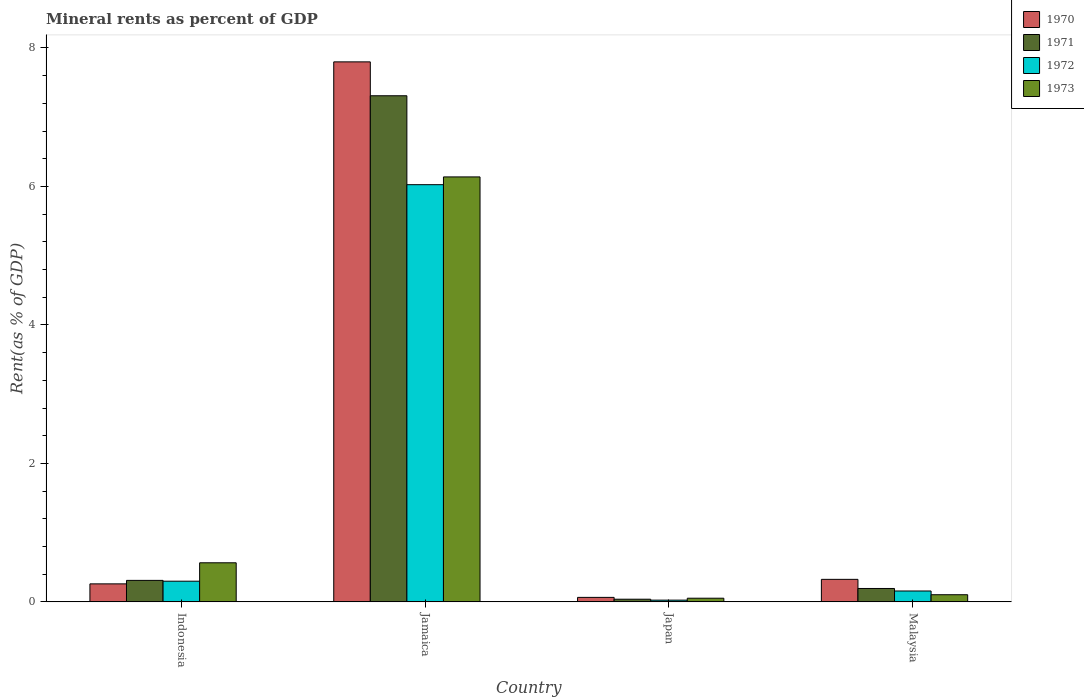How many different coloured bars are there?
Provide a short and direct response. 4. How many groups of bars are there?
Provide a succinct answer. 4. Are the number of bars per tick equal to the number of legend labels?
Offer a very short reply. Yes. How many bars are there on the 4th tick from the right?
Provide a succinct answer. 4. What is the mineral rent in 1970 in Indonesia?
Give a very brief answer. 0.26. Across all countries, what is the maximum mineral rent in 1973?
Offer a terse response. 6.14. Across all countries, what is the minimum mineral rent in 1973?
Your answer should be very brief. 0.05. In which country was the mineral rent in 1972 maximum?
Offer a terse response. Jamaica. In which country was the mineral rent in 1973 minimum?
Your response must be concise. Japan. What is the total mineral rent in 1970 in the graph?
Provide a succinct answer. 8.45. What is the difference between the mineral rent in 1971 in Jamaica and that in Japan?
Give a very brief answer. 7.27. What is the difference between the mineral rent in 1971 in Jamaica and the mineral rent in 1970 in Japan?
Give a very brief answer. 7.25. What is the average mineral rent in 1973 per country?
Ensure brevity in your answer.  1.71. What is the difference between the mineral rent of/in 1970 and mineral rent of/in 1971 in Jamaica?
Ensure brevity in your answer.  0.49. What is the ratio of the mineral rent in 1970 in Japan to that in Malaysia?
Your response must be concise. 0.2. What is the difference between the highest and the second highest mineral rent in 1971?
Keep it short and to the point. 0.12. What is the difference between the highest and the lowest mineral rent in 1972?
Keep it short and to the point. 6. In how many countries, is the mineral rent in 1973 greater than the average mineral rent in 1973 taken over all countries?
Provide a succinct answer. 1. Is it the case that in every country, the sum of the mineral rent in 1971 and mineral rent in 1970 is greater than the sum of mineral rent in 1973 and mineral rent in 1972?
Provide a short and direct response. No. What does the 3rd bar from the right in Indonesia represents?
Provide a short and direct response. 1971. How many bars are there?
Offer a terse response. 16. Are the values on the major ticks of Y-axis written in scientific E-notation?
Offer a terse response. No. Does the graph contain grids?
Your answer should be compact. No. How are the legend labels stacked?
Provide a succinct answer. Vertical. What is the title of the graph?
Keep it short and to the point. Mineral rents as percent of GDP. What is the label or title of the X-axis?
Give a very brief answer. Country. What is the label or title of the Y-axis?
Your answer should be compact. Rent(as % of GDP). What is the Rent(as % of GDP) in 1970 in Indonesia?
Give a very brief answer. 0.26. What is the Rent(as % of GDP) in 1971 in Indonesia?
Make the answer very short. 0.31. What is the Rent(as % of GDP) of 1972 in Indonesia?
Offer a very short reply. 0.3. What is the Rent(as % of GDP) in 1973 in Indonesia?
Offer a very short reply. 0.56. What is the Rent(as % of GDP) in 1970 in Jamaica?
Provide a short and direct response. 7.8. What is the Rent(as % of GDP) in 1971 in Jamaica?
Give a very brief answer. 7.31. What is the Rent(as % of GDP) in 1972 in Jamaica?
Provide a short and direct response. 6.03. What is the Rent(as % of GDP) in 1973 in Jamaica?
Your answer should be compact. 6.14. What is the Rent(as % of GDP) of 1970 in Japan?
Give a very brief answer. 0.06. What is the Rent(as % of GDP) in 1971 in Japan?
Your response must be concise. 0.04. What is the Rent(as % of GDP) in 1972 in Japan?
Give a very brief answer. 0.03. What is the Rent(as % of GDP) in 1973 in Japan?
Keep it short and to the point. 0.05. What is the Rent(as % of GDP) of 1970 in Malaysia?
Make the answer very short. 0.33. What is the Rent(as % of GDP) in 1971 in Malaysia?
Your answer should be compact. 0.19. What is the Rent(as % of GDP) of 1972 in Malaysia?
Offer a terse response. 0.16. What is the Rent(as % of GDP) of 1973 in Malaysia?
Provide a succinct answer. 0.1. Across all countries, what is the maximum Rent(as % of GDP) in 1970?
Your answer should be compact. 7.8. Across all countries, what is the maximum Rent(as % of GDP) of 1971?
Ensure brevity in your answer.  7.31. Across all countries, what is the maximum Rent(as % of GDP) in 1972?
Offer a terse response. 6.03. Across all countries, what is the maximum Rent(as % of GDP) of 1973?
Ensure brevity in your answer.  6.14. Across all countries, what is the minimum Rent(as % of GDP) in 1970?
Offer a very short reply. 0.06. Across all countries, what is the minimum Rent(as % of GDP) of 1971?
Give a very brief answer. 0.04. Across all countries, what is the minimum Rent(as % of GDP) of 1972?
Provide a succinct answer. 0.03. Across all countries, what is the minimum Rent(as % of GDP) in 1973?
Provide a short and direct response. 0.05. What is the total Rent(as % of GDP) in 1970 in the graph?
Offer a very short reply. 8.45. What is the total Rent(as % of GDP) in 1971 in the graph?
Your response must be concise. 7.85. What is the total Rent(as % of GDP) in 1972 in the graph?
Keep it short and to the point. 6.51. What is the total Rent(as % of GDP) of 1973 in the graph?
Give a very brief answer. 6.86. What is the difference between the Rent(as % of GDP) of 1970 in Indonesia and that in Jamaica?
Your response must be concise. -7.54. What is the difference between the Rent(as % of GDP) in 1971 in Indonesia and that in Jamaica?
Provide a succinct answer. -7. What is the difference between the Rent(as % of GDP) in 1972 in Indonesia and that in Jamaica?
Provide a succinct answer. -5.73. What is the difference between the Rent(as % of GDP) in 1973 in Indonesia and that in Jamaica?
Provide a short and direct response. -5.57. What is the difference between the Rent(as % of GDP) of 1970 in Indonesia and that in Japan?
Provide a succinct answer. 0.2. What is the difference between the Rent(as % of GDP) in 1971 in Indonesia and that in Japan?
Your answer should be compact. 0.27. What is the difference between the Rent(as % of GDP) of 1972 in Indonesia and that in Japan?
Give a very brief answer. 0.27. What is the difference between the Rent(as % of GDP) of 1973 in Indonesia and that in Japan?
Offer a very short reply. 0.51. What is the difference between the Rent(as % of GDP) of 1970 in Indonesia and that in Malaysia?
Offer a very short reply. -0.07. What is the difference between the Rent(as % of GDP) in 1971 in Indonesia and that in Malaysia?
Give a very brief answer. 0.12. What is the difference between the Rent(as % of GDP) in 1972 in Indonesia and that in Malaysia?
Keep it short and to the point. 0.14. What is the difference between the Rent(as % of GDP) of 1973 in Indonesia and that in Malaysia?
Make the answer very short. 0.46. What is the difference between the Rent(as % of GDP) of 1970 in Jamaica and that in Japan?
Provide a succinct answer. 7.73. What is the difference between the Rent(as % of GDP) in 1971 in Jamaica and that in Japan?
Keep it short and to the point. 7.27. What is the difference between the Rent(as % of GDP) in 1972 in Jamaica and that in Japan?
Provide a succinct answer. 6. What is the difference between the Rent(as % of GDP) in 1973 in Jamaica and that in Japan?
Your response must be concise. 6.08. What is the difference between the Rent(as % of GDP) in 1970 in Jamaica and that in Malaysia?
Provide a succinct answer. 7.47. What is the difference between the Rent(as % of GDP) in 1971 in Jamaica and that in Malaysia?
Your response must be concise. 7.12. What is the difference between the Rent(as % of GDP) in 1972 in Jamaica and that in Malaysia?
Your answer should be very brief. 5.87. What is the difference between the Rent(as % of GDP) in 1973 in Jamaica and that in Malaysia?
Offer a terse response. 6.03. What is the difference between the Rent(as % of GDP) in 1970 in Japan and that in Malaysia?
Ensure brevity in your answer.  -0.26. What is the difference between the Rent(as % of GDP) of 1971 in Japan and that in Malaysia?
Your answer should be compact. -0.16. What is the difference between the Rent(as % of GDP) of 1972 in Japan and that in Malaysia?
Provide a short and direct response. -0.13. What is the difference between the Rent(as % of GDP) of 1973 in Japan and that in Malaysia?
Your answer should be compact. -0.05. What is the difference between the Rent(as % of GDP) of 1970 in Indonesia and the Rent(as % of GDP) of 1971 in Jamaica?
Make the answer very short. -7.05. What is the difference between the Rent(as % of GDP) of 1970 in Indonesia and the Rent(as % of GDP) of 1972 in Jamaica?
Provide a short and direct response. -5.77. What is the difference between the Rent(as % of GDP) of 1970 in Indonesia and the Rent(as % of GDP) of 1973 in Jamaica?
Provide a succinct answer. -5.88. What is the difference between the Rent(as % of GDP) of 1971 in Indonesia and the Rent(as % of GDP) of 1972 in Jamaica?
Make the answer very short. -5.72. What is the difference between the Rent(as % of GDP) in 1971 in Indonesia and the Rent(as % of GDP) in 1973 in Jamaica?
Give a very brief answer. -5.83. What is the difference between the Rent(as % of GDP) of 1972 in Indonesia and the Rent(as % of GDP) of 1973 in Jamaica?
Your answer should be very brief. -5.84. What is the difference between the Rent(as % of GDP) of 1970 in Indonesia and the Rent(as % of GDP) of 1971 in Japan?
Keep it short and to the point. 0.22. What is the difference between the Rent(as % of GDP) of 1970 in Indonesia and the Rent(as % of GDP) of 1972 in Japan?
Give a very brief answer. 0.23. What is the difference between the Rent(as % of GDP) in 1970 in Indonesia and the Rent(as % of GDP) in 1973 in Japan?
Give a very brief answer. 0.21. What is the difference between the Rent(as % of GDP) of 1971 in Indonesia and the Rent(as % of GDP) of 1972 in Japan?
Keep it short and to the point. 0.29. What is the difference between the Rent(as % of GDP) of 1971 in Indonesia and the Rent(as % of GDP) of 1973 in Japan?
Give a very brief answer. 0.26. What is the difference between the Rent(as % of GDP) in 1972 in Indonesia and the Rent(as % of GDP) in 1973 in Japan?
Offer a terse response. 0.25. What is the difference between the Rent(as % of GDP) in 1970 in Indonesia and the Rent(as % of GDP) in 1971 in Malaysia?
Your answer should be very brief. 0.07. What is the difference between the Rent(as % of GDP) of 1970 in Indonesia and the Rent(as % of GDP) of 1972 in Malaysia?
Give a very brief answer. 0.1. What is the difference between the Rent(as % of GDP) of 1970 in Indonesia and the Rent(as % of GDP) of 1973 in Malaysia?
Your response must be concise. 0.16. What is the difference between the Rent(as % of GDP) of 1971 in Indonesia and the Rent(as % of GDP) of 1972 in Malaysia?
Provide a short and direct response. 0.15. What is the difference between the Rent(as % of GDP) of 1971 in Indonesia and the Rent(as % of GDP) of 1973 in Malaysia?
Provide a succinct answer. 0.21. What is the difference between the Rent(as % of GDP) in 1972 in Indonesia and the Rent(as % of GDP) in 1973 in Malaysia?
Keep it short and to the point. 0.2. What is the difference between the Rent(as % of GDP) in 1970 in Jamaica and the Rent(as % of GDP) in 1971 in Japan?
Provide a short and direct response. 7.76. What is the difference between the Rent(as % of GDP) in 1970 in Jamaica and the Rent(as % of GDP) in 1972 in Japan?
Offer a terse response. 7.77. What is the difference between the Rent(as % of GDP) in 1970 in Jamaica and the Rent(as % of GDP) in 1973 in Japan?
Make the answer very short. 7.75. What is the difference between the Rent(as % of GDP) in 1971 in Jamaica and the Rent(as % of GDP) in 1972 in Japan?
Your answer should be compact. 7.28. What is the difference between the Rent(as % of GDP) of 1971 in Jamaica and the Rent(as % of GDP) of 1973 in Japan?
Your answer should be very brief. 7.26. What is the difference between the Rent(as % of GDP) of 1972 in Jamaica and the Rent(as % of GDP) of 1973 in Japan?
Your answer should be compact. 5.97. What is the difference between the Rent(as % of GDP) of 1970 in Jamaica and the Rent(as % of GDP) of 1971 in Malaysia?
Make the answer very short. 7.61. What is the difference between the Rent(as % of GDP) in 1970 in Jamaica and the Rent(as % of GDP) in 1972 in Malaysia?
Offer a very short reply. 7.64. What is the difference between the Rent(as % of GDP) of 1970 in Jamaica and the Rent(as % of GDP) of 1973 in Malaysia?
Keep it short and to the point. 7.7. What is the difference between the Rent(as % of GDP) of 1971 in Jamaica and the Rent(as % of GDP) of 1972 in Malaysia?
Your answer should be very brief. 7.15. What is the difference between the Rent(as % of GDP) in 1971 in Jamaica and the Rent(as % of GDP) in 1973 in Malaysia?
Make the answer very short. 7.21. What is the difference between the Rent(as % of GDP) of 1972 in Jamaica and the Rent(as % of GDP) of 1973 in Malaysia?
Your answer should be compact. 5.92. What is the difference between the Rent(as % of GDP) in 1970 in Japan and the Rent(as % of GDP) in 1971 in Malaysia?
Your answer should be compact. -0.13. What is the difference between the Rent(as % of GDP) in 1970 in Japan and the Rent(as % of GDP) in 1972 in Malaysia?
Your answer should be compact. -0.09. What is the difference between the Rent(as % of GDP) in 1970 in Japan and the Rent(as % of GDP) in 1973 in Malaysia?
Offer a very short reply. -0.04. What is the difference between the Rent(as % of GDP) in 1971 in Japan and the Rent(as % of GDP) in 1972 in Malaysia?
Your response must be concise. -0.12. What is the difference between the Rent(as % of GDP) of 1971 in Japan and the Rent(as % of GDP) of 1973 in Malaysia?
Offer a very short reply. -0.06. What is the difference between the Rent(as % of GDP) of 1972 in Japan and the Rent(as % of GDP) of 1973 in Malaysia?
Give a very brief answer. -0.08. What is the average Rent(as % of GDP) in 1970 per country?
Make the answer very short. 2.11. What is the average Rent(as % of GDP) in 1971 per country?
Give a very brief answer. 1.96. What is the average Rent(as % of GDP) of 1972 per country?
Offer a very short reply. 1.63. What is the average Rent(as % of GDP) in 1973 per country?
Provide a short and direct response. 1.71. What is the difference between the Rent(as % of GDP) of 1970 and Rent(as % of GDP) of 1971 in Indonesia?
Keep it short and to the point. -0.05. What is the difference between the Rent(as % of GDP) in 1970 and Rent(as % of GDP) in 1972 in Indonesia?
Your answer should be very brief. -0.04. What is the difference between the Rent(as % of GDP) in 1970 and Rent(as % of GDP) in 1973 in Indonesia?
Make the answer very short. -0.3. What is the difference between the Rent(as % of GDP) in 1971 and Rent(as % of GDP) in 1972 in Indonesia?
Offer a very short reply. 0.01. What is the difference between the Rent(as % of GDP) of 1971 and Rent(as % of GDP) of 1973 in Indonesia?
Make the answer very short. -0.25. What is the difference between the Rent(as % of GDP) of 1972 and Rent(as % of GDP) of 1973 in Indonesia?
Keep it short and to the point. -0.27. What is the difference between the Rent(as % of GDP) in 1970 and Rent(as % of GDP) in 1971 in Jamaica?
Offer a very short reply. 0.49. What is the difference between the Rent(as % of GDP) of 1970 and Rent(as % of GDP) of 1972 in Jamaica?
Your answer should be compact. 1.77. What is the difference between the Rent(as % of GDP) of 1970 and Rent(as % of GDP) of 1973 in Jamaica?
Give a very brief answer. 1.66. What is the difference between the Rent(as % of GDP) of 1971 and Rent(as % of GDP) of 1972 in Jamaica?
Ensure brevity in your answer.  1.28. What is the difference between the Rent(as % of GDP) in 1971 and Rent(as % of GDP) in 1973 in Jamaica?
Ensure brevity in your answer.  1.17. What is the difference between the Rent(as % of GDP) in 1972 and Rent(as % of GDP) in 1973 in Jamaica?
Ensure brevity in your answer.  -0.11. What is the difference between the Rent(as % of GDP) in 1970 and Rent(as % of GDP) in 1971 in Japan?
Offer a terse response. 0.03. What is the difference between the Rent(as % of GDP) of 1970 and Rent(as % of GDP) of 1972 in Japan?
Provide a succinct answer. 0.04. What is the difference between the Rent(as % of GDP) of 1970 and Rent(as % of GDP) of 1973 in Japan?
Offer a terse response. 0.01. What is the difference between the Rent(as % of GDP) in 1971 and Rent(as % of GDP) in 1972 in Japan?
Your answer should be very brief. 0.01. What is the difference between the Rent(as % of GDP) of 1971 and Rent(as % of GDP) of 1973 in Japan?
Ensure brevity in your answer.  -0.01. What is the difference between the Rent(as % of GDP) of 1972 and Rent(as % of GDP) of 1973 in Japan?
Provide a succinct answer. -0.03. What is the difference between the Rent(as % of GDP) in 1970 and Rent(as % of GDP) in 1971 in Malaysia?
Offer a very short reply. 0.13. What is the difference between the Rent(as % of GDP) in 1970 and Rent(as % of GDP) in 1972 in Malaysia?
Offer a terse response. 0.17. What is the difference between the Rent(as % of GDP) in 1970 and Rent(as % of GDP) in 1973 in Malaysia?
Make the answer very short. 0.22. What is the difference between the Rent(as % of GDP) of 1971 and Rent(as % of GDP) of 1972 in Malaysia?
Ensure brevity in your answer.  0.04. What is the difference between the Rent(as % of GDP) of 1971 and Rent(as % of GDP) of 1973 in Malaysia?
Keep it short and to the point. 0.09. What is the difference between the Rent(as % of GDP) of 1972 and Rent(as % of GDP) of 1973 in Malaysia?
Keep it short and to the point. 0.05. What is the ratio of the Rent(as % of GDP) of 1970 in Indonesia to that in Jamaica?
Provide a succinct answer. 0.03. What is the ratio of the Rent(as % of GDP) in 1971 in Indonesia to that in Jamaica?
Offer a terse response. 0.04. What is the ratio of the Rent(as % of GDP) of 1972 in Indonesia to that in Jamaica?
Keep it short and to the point. 0.05. What is the ratio of the Rent(as % of GDP) of 1973 in Indonesia to that in Jamaica?
Provide a succinct answer. 0.09. What is the ratio of the Rent(as % of GDP) of 1970 in Indonesia to that in Japan?
Make the answer very short. 4.01. What is the ratio of the Rent(as % of GDP) in 1971 in Indonesia to that in Japan?
Your answer should be very brief. 8.06. What is the ratio of the Rent(as % of GDP) in 1972 in Indonesia to that in Japan?
Ensure brevity in your answer.  11.82. What is the ratio of the Rent(as % of GDP) in 1973 in Indonesia to that in Japan?
Offer a terse response. 10.69. What is the ratio of the Rent(as % of GDP) in 1970 in Indonesia to that in Malaysia?
Make the answer very short. 0.8. What is the ratio of the Rent(as % of GDP) of 1971 in Indonesia to that in Malaysia?
Your answer should be compact. 1.6. What is the ratio of the Rent(as % of GDP) in 1972 in Indonesia to that in Malaysia?
Keep it short and to the point. 1.9. What is the ratio of the Rent(as % of GDP) of 1973 in Indonesia to that in Malaysia?
Ensure brevity in your answer.  5.47. What is the ratio of the Rent(as % of GDP) in 1970 in Jamaica to that in Japan?
Offer a very short reply. 120.23. What is the ratio of the Rent(as % of GDP) in 1971 in Jamaica to that in Japan?
Provide a succinct answer. 189.73. What is the ratio of the Rent(as % of GDP) of 1972 in Jamaica to that in Japan?
Your answer should be very brief. 238.51. What is the ratio of the Rent(as % of GDP) in 1973 in Jamaica to that in Japan?
Make the answer very short. 116.18. What is the ratio of the Rent(as % of GDP) in 1970 in Jamaica to that in Malaysia?
Make the answer very short. 23.97. What is the ratio of the Rent(as % of GDP) of 1971 in Jamaica to that in Malaysia?
Your response must be concise. 37.76. What is the ratio of the Rent(as % of GDP) in 1972 in Jamaica to that in Malaysia?
Provide a short and direct response. 38.36. What is the ratio of the Rent(as % of GDP) in 1973 in Jamaica to that in Malaysia?
Ensure brevity in your answer.  59.49. What is the ratio of the Rent(as % of GDP) of 1970 in Japan to that in Malaysia?
Provide a short and direct response. 0.2. What is the ratio of the Rent(as % of GDP) of 1971 in Japan to that in Malaysia?
Provide a short and direct response. 0.2. What is the ratio of the Rent(as % of GDP) in 1972 in Japan to that in Malaysia?
Make the answer very short. 0.16. What is the ratio of the Rent(as % of GDP) in 1973 in Japan to that in Malaysia?
Ensure brevity in your answer.  0.51. What is the difference between the highest and the second highest Rent(as % of GDP) in 1970?
Ensure brevity in your answer.  7.47. What is the difference between the highest and the second highest Rent(as % of GDP) in 1971?
Your answer should be very brief. 7. What is the difference between the highest and the second highest Rent(as % of GDP) of 1972?
Your answer should be compact. 5.73. What is the difference between the highest and the second highest Rent(as % of GDP) of 1973?
Keep it short and to the point. 5.57. What is the difference between the highest and the lowest Rent(as % of GDP) in 1970?
Your answer should be very brief. 7.73. What is the difference between the highest and the lowest Rent(as % of GDP) in 1971?
Your answer should be compact. 7.27. What is the difference between the highest and the lowest Rent(as % of GDP) of 1972?
Ensure brevity in your answer.  6. What is the difference between the highest and the lowest Rent(as % of GDP) in 1973?
Offer a very short reply. 6.08. 